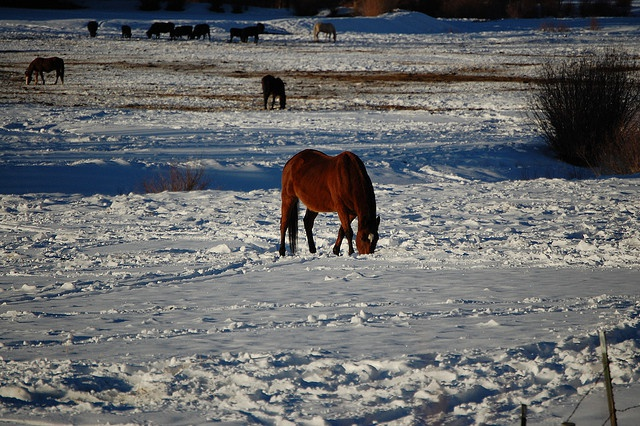Describe the objects in this image and their specific colors. I can see horse in black, maroon, gray, and darkgray tones, horse in black, gray, and maroon tones, horse in black, gray, and maroon tones, horse in black, gray, and navy tones, and horse in black and gray tones in this image. 